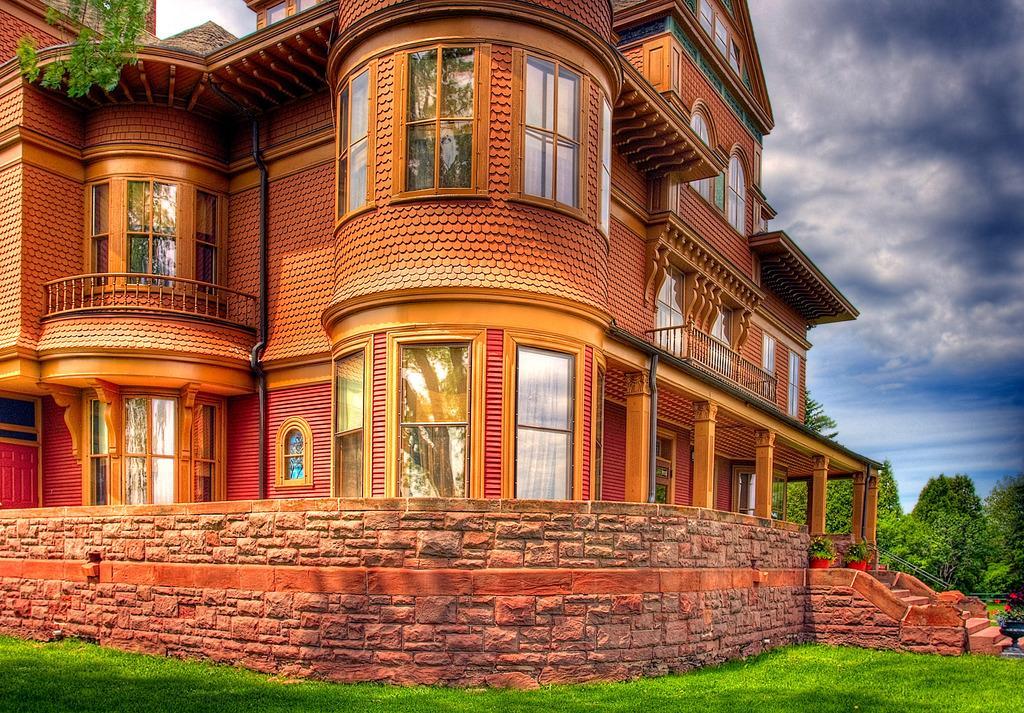Could you give a brief overview of what you see in this image? In this image we can see a building, windows, wall, grass, plants, flowers, and trees. In the background there is sky with clouds. 